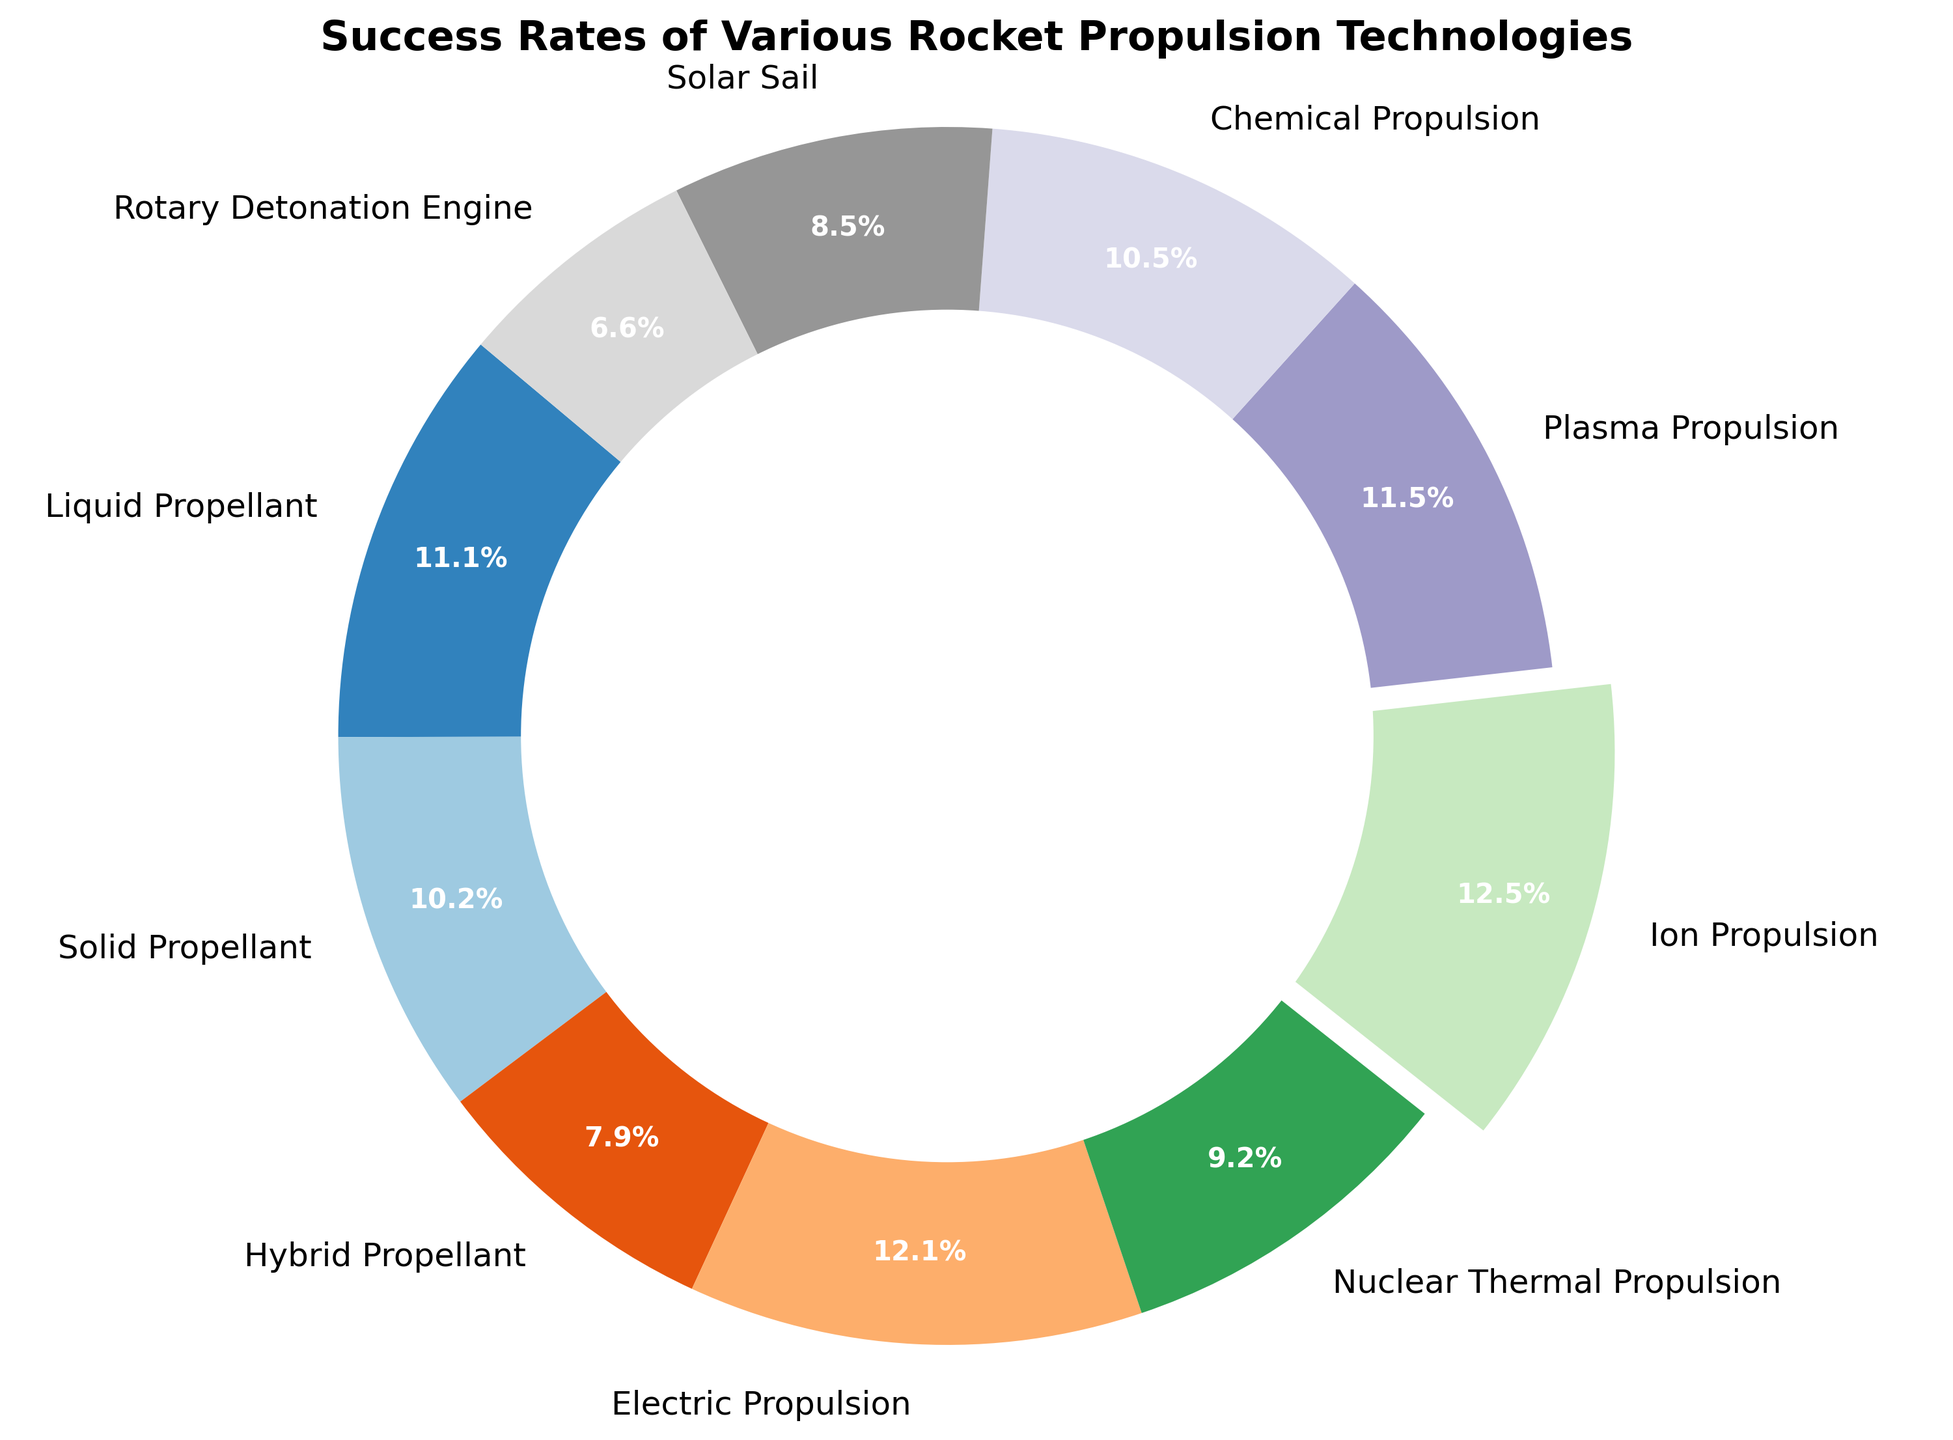What's the technology with the highest success rate? Look for the technology with the highest percentage. Ion Propulsion has the highest success rate at 95%.
Answer: Ion Propulsion What's the success rate difference between Electric Propulsion and Nuclear Thermal Propulsion? Deduct the success rate of Nuclear Thermal Propulsion from Electric Propulsion's rate: 92% - 70% = 22%.
Answer: 22% Which two technologies have the smallest difference in success rates? Compare the success rates of all technologies to find the smallest difference. Liquid Propellant (85%) and Plasma Propulsion (88%) differ by only 3%.
Answer: Liquid Propellant and Plasma Propulsion How many technologies have a success rate of 80% or above? Count the number of technologies with a success rate of 80% or above. Liquid Propellant (85%), Electric Propulsion (92%), Ion Propulsion (95%), Plasma Propulsion (88%), and Chemical Propulsion (80%) total five technologies.
Answer: 5 Which technology has the smallest success rate, and what is it? Identify the technology with the smallest percentage. Rotary Detonation Engine has the smallest success rate at 50%.
Answer: Rotary Detonation Engine with 50% What is the average success rate of Solid Propellant, Hybrid Propellant, and Solar Sail? Sum their success rates and divide by the number of technologies: (78% + 60% + 65%)/3 = 67.67%.
Answer: 67.67% Is the success rate of Hybrid Propellant above or below the overall average success rate? Calculate the overall average: (sum of all rates)/10 = (85 + 78 + 60 + 92 + 70 + 95 + 88 + 80 + 65 + 50)/10 = 763/10 = 76.3%. Hybrid Propellant's rate is 60%, which is below 76.3%.
Answer: Below How many technologies have success rates between 60% and 90%? Count how many technologies fall within this range. 7 technologies: Liquid Propellant, Solid Propellant, Hybrid Propellant, Plasma Propulsion, Chemical Propulsion, Solar Sail, and Nuclear Thermal Propulsion.
Answer: 7 Which technology slice is separated from the others, and why? Identify the slice that is visually separated. Ion Propulsion is separated because it has the highest success rate at 95%.
Answer: Ion Propulsion By what percentage does the success rate of Electric Propulsion exceed that of Chemical Propulsion? Subtract Chemical Propulsion's rate from Electric Propulsion's rate: 92% - 80% = 12%.
Answer: 12% 